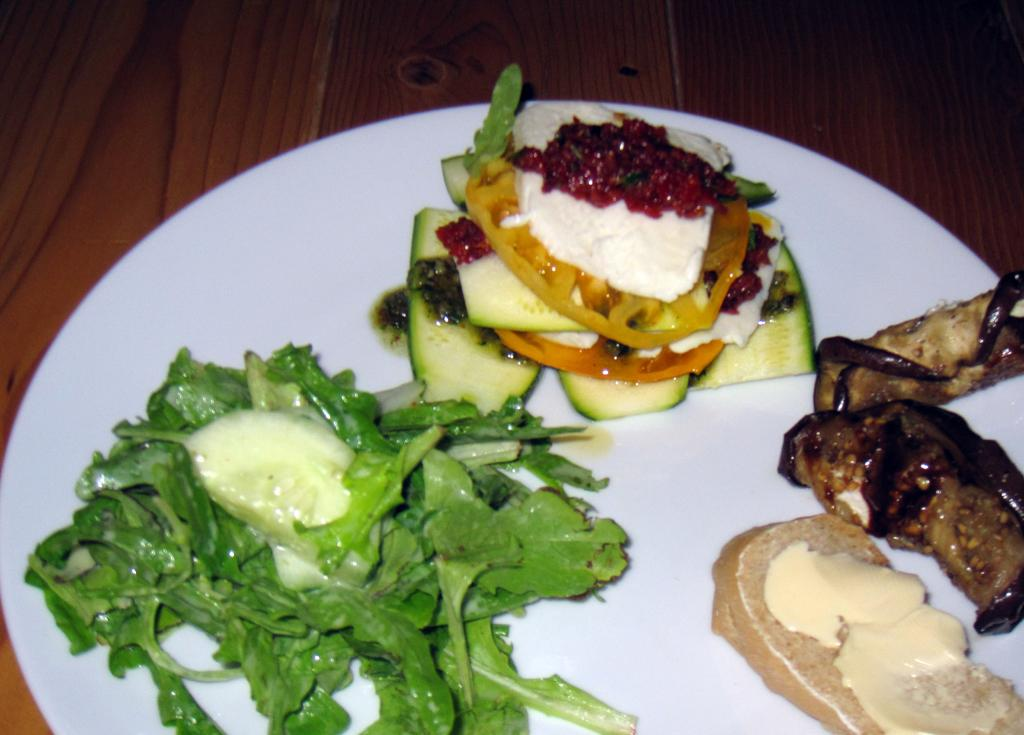What is on the plate that is visible in the image? There are food items on a plate. What is the plate placed on in the image? The plate is on a wooden surface. How does the airplane help with the food preparation in the image? There is no airplane present in the image, and therefore it does not contribute to the food preparation. 